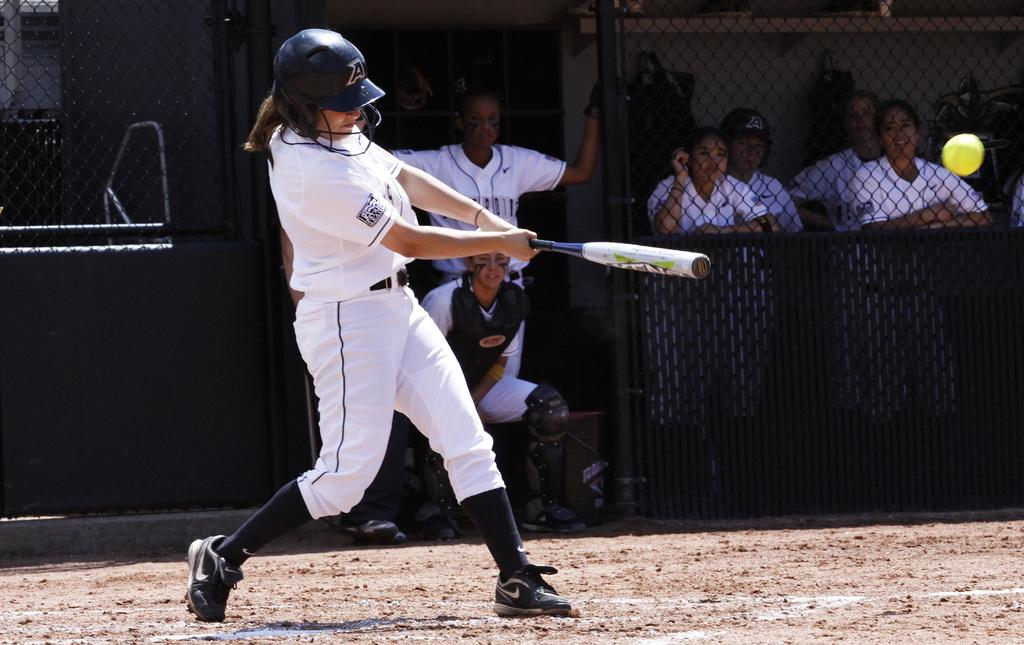<image>
Provide a brief description of the given image. Baseball player wearing a helmet that has the letter A on it. 